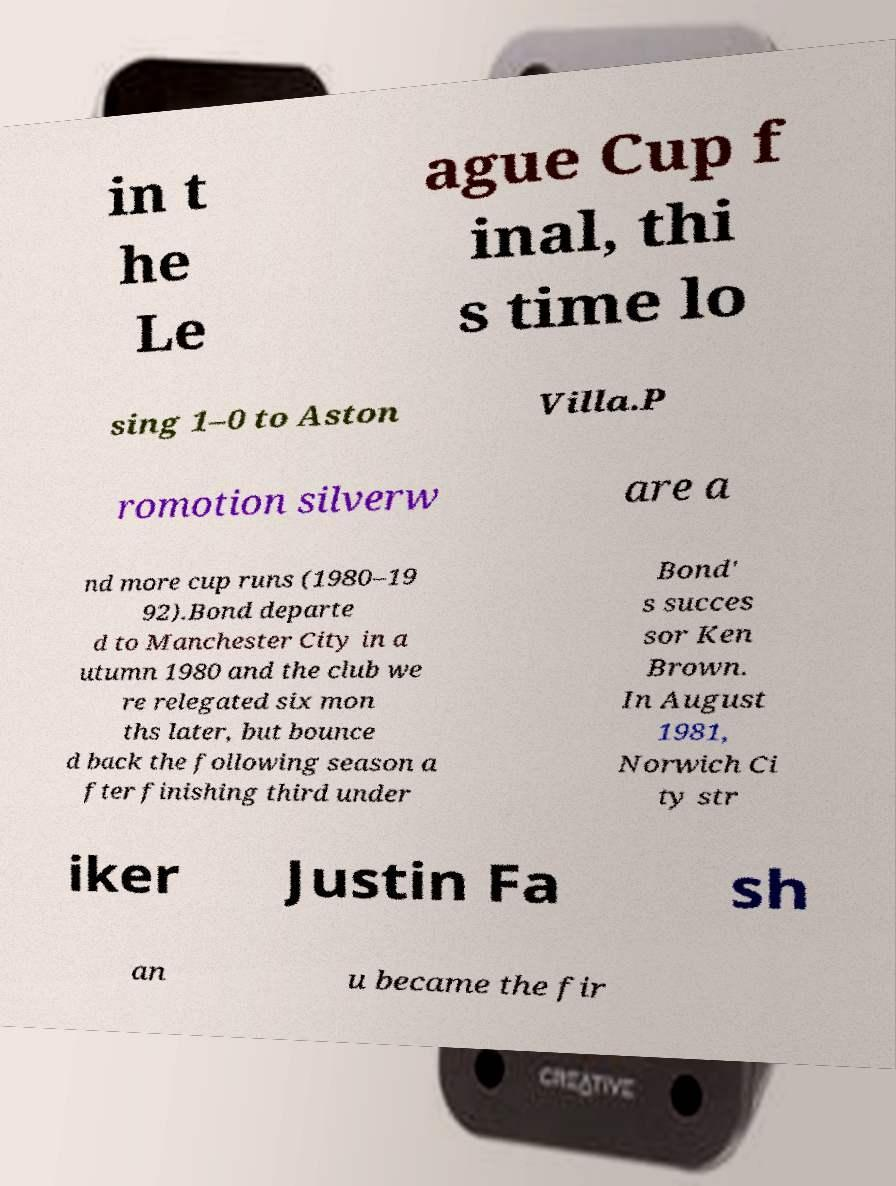Could you extract and type out the text from this image? in t he Le ague Cup f inal, thi s time lo sing 1–0 to Aston Villa.P romotion silverw are a nd more cup runs (1980–19 92).Bond departe d to Manchester City in a utumn 1980 and the club we re relegated six mon ths later, but bounce d back the following season a fter finishing third under Bond' s succes sor Ken Brown. In August 1981, Norwich Ci ty str iker Justin Fa sh an u became the fir 